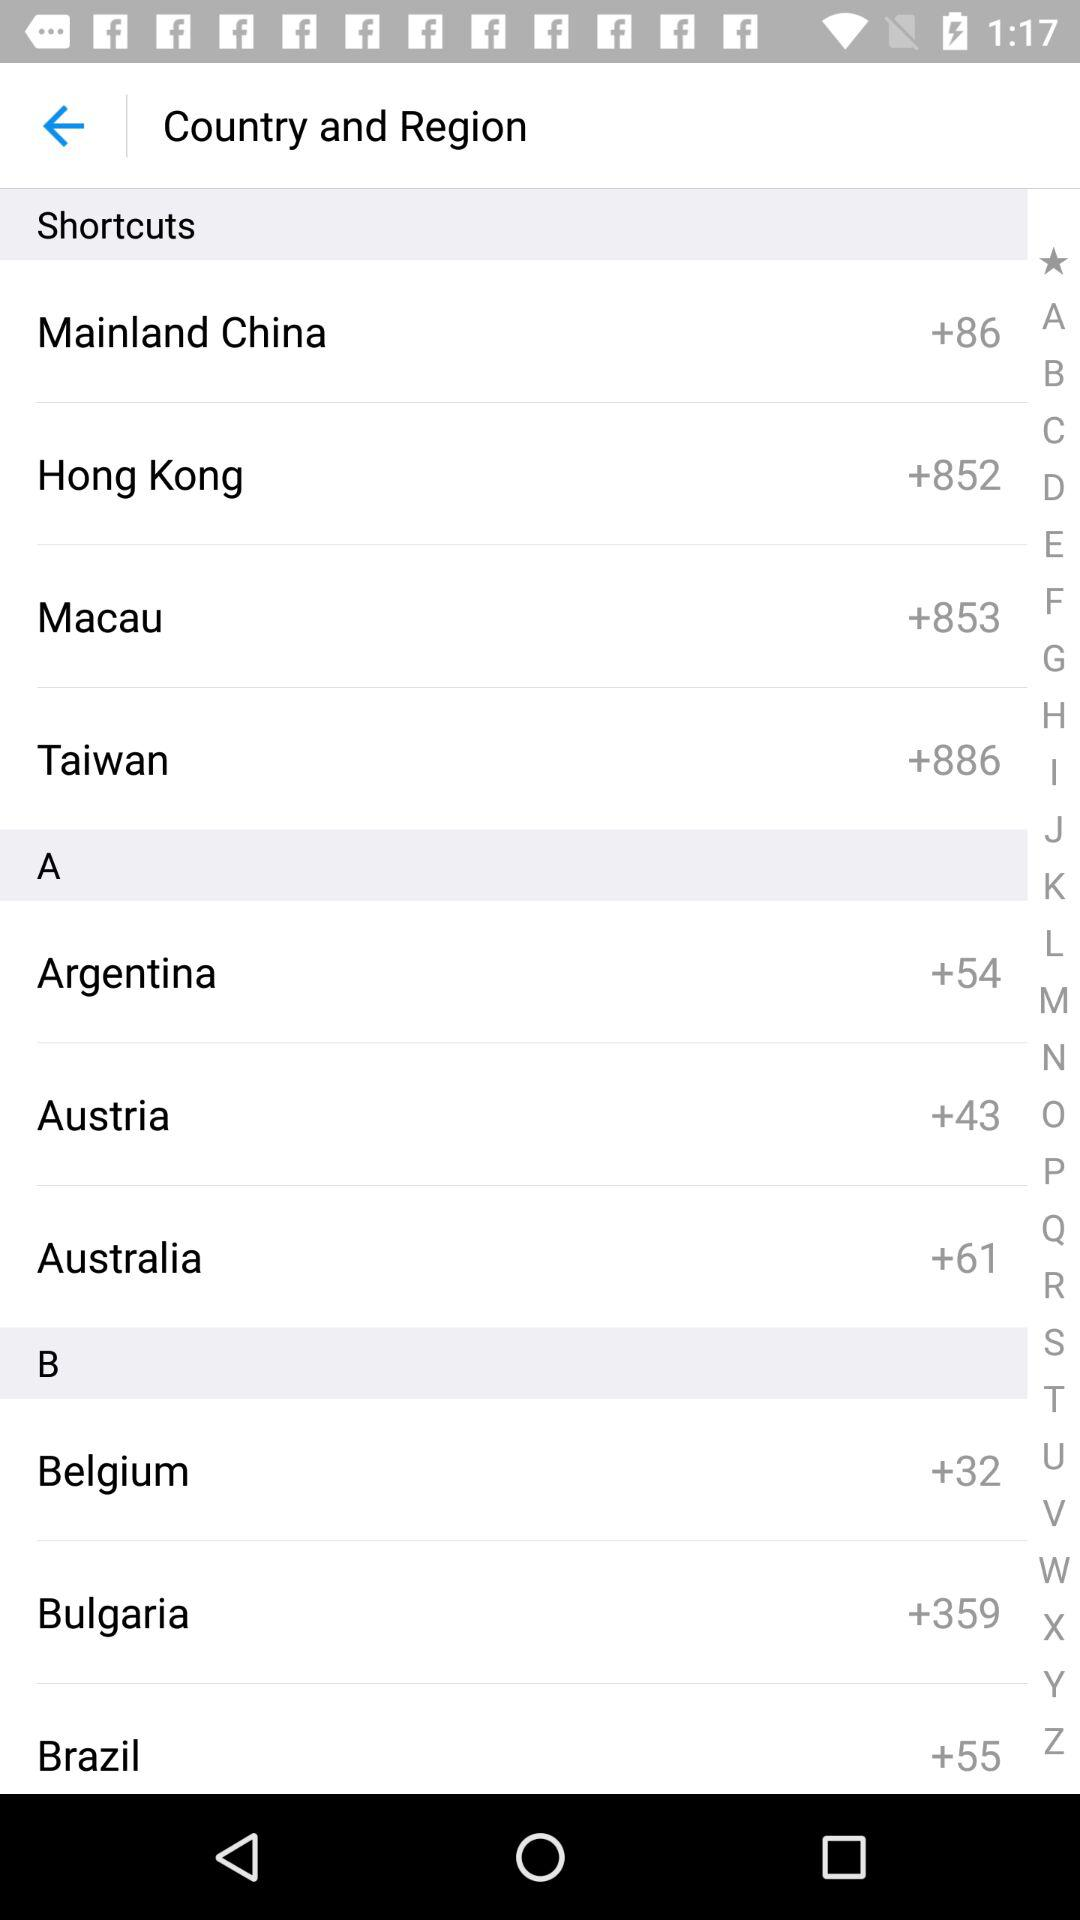Which country has the code +54? The country is Argentina. 